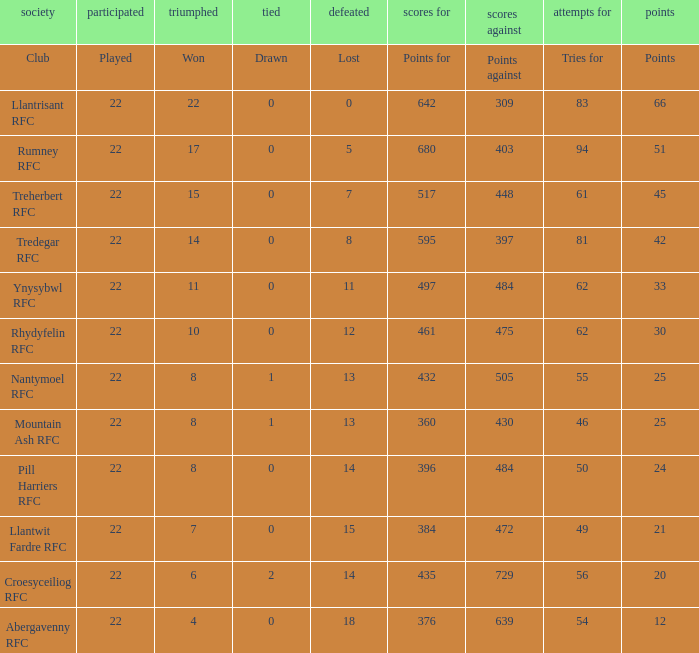In the case of teams that secured 15 triumphs, how many points did they tally? 45.0. 